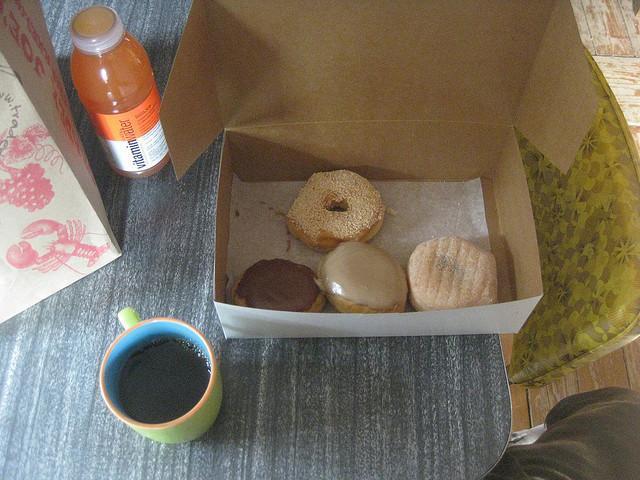How many donuts are left?
Give a very brief answer. 4. How many donuts are in the photo?
Give a very brief answer. 4. How many people are standing to the left of the open train door?
Give a very brief answer. 0. 